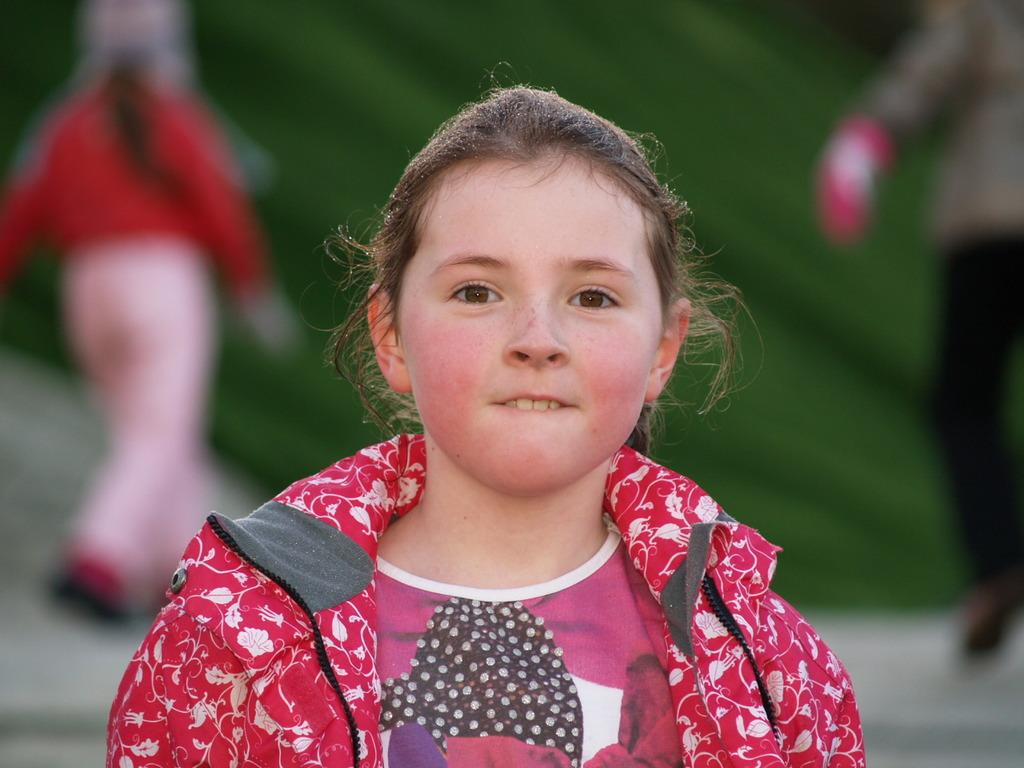Who is the main subject in the image? There is a girl in the image. What is the girl wearing? The girl is wearing a pink dress. Can you describe the background of the image? There are two people and grass in the background of the image, and the background is blurred. What type of hat is the girl wearing in the image? The girl is not wearing a hat in the image. Can you describe the crime scene depicted in the image? There is no crime scene present in the image; it features a girl in a pink dress with a blurred background. 